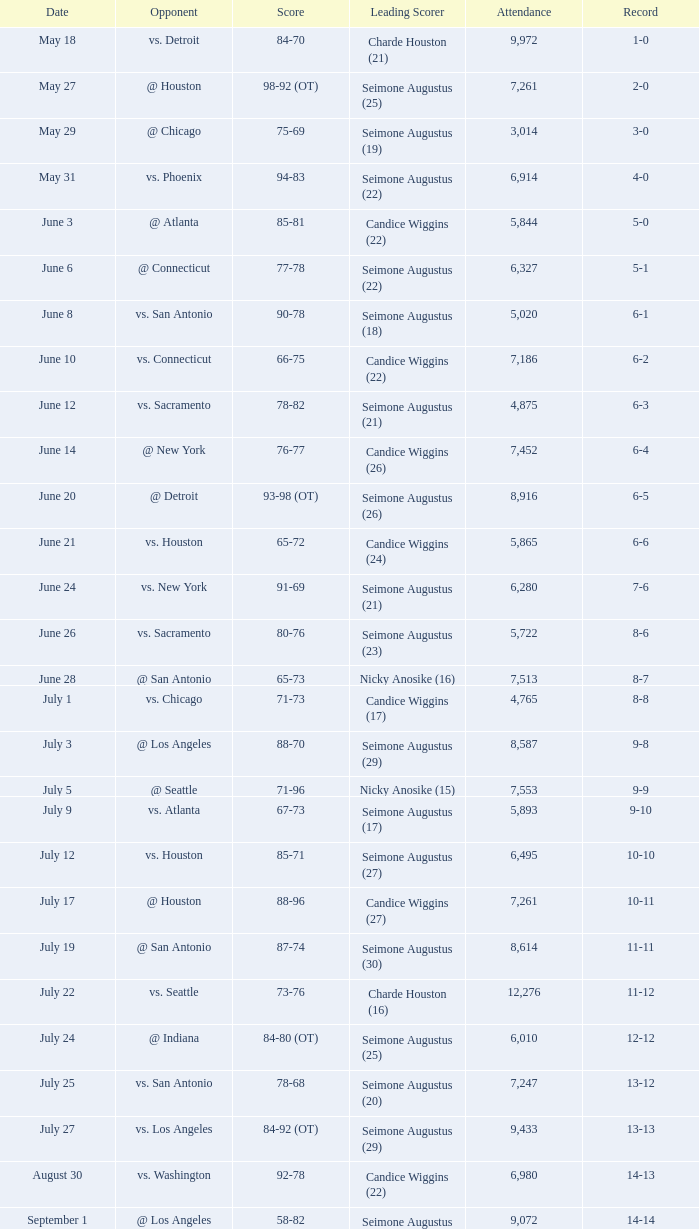Which Leading Scorer has an Opponent of @ seattle, and a Record of 14-16? Seimone Augustus (26). 